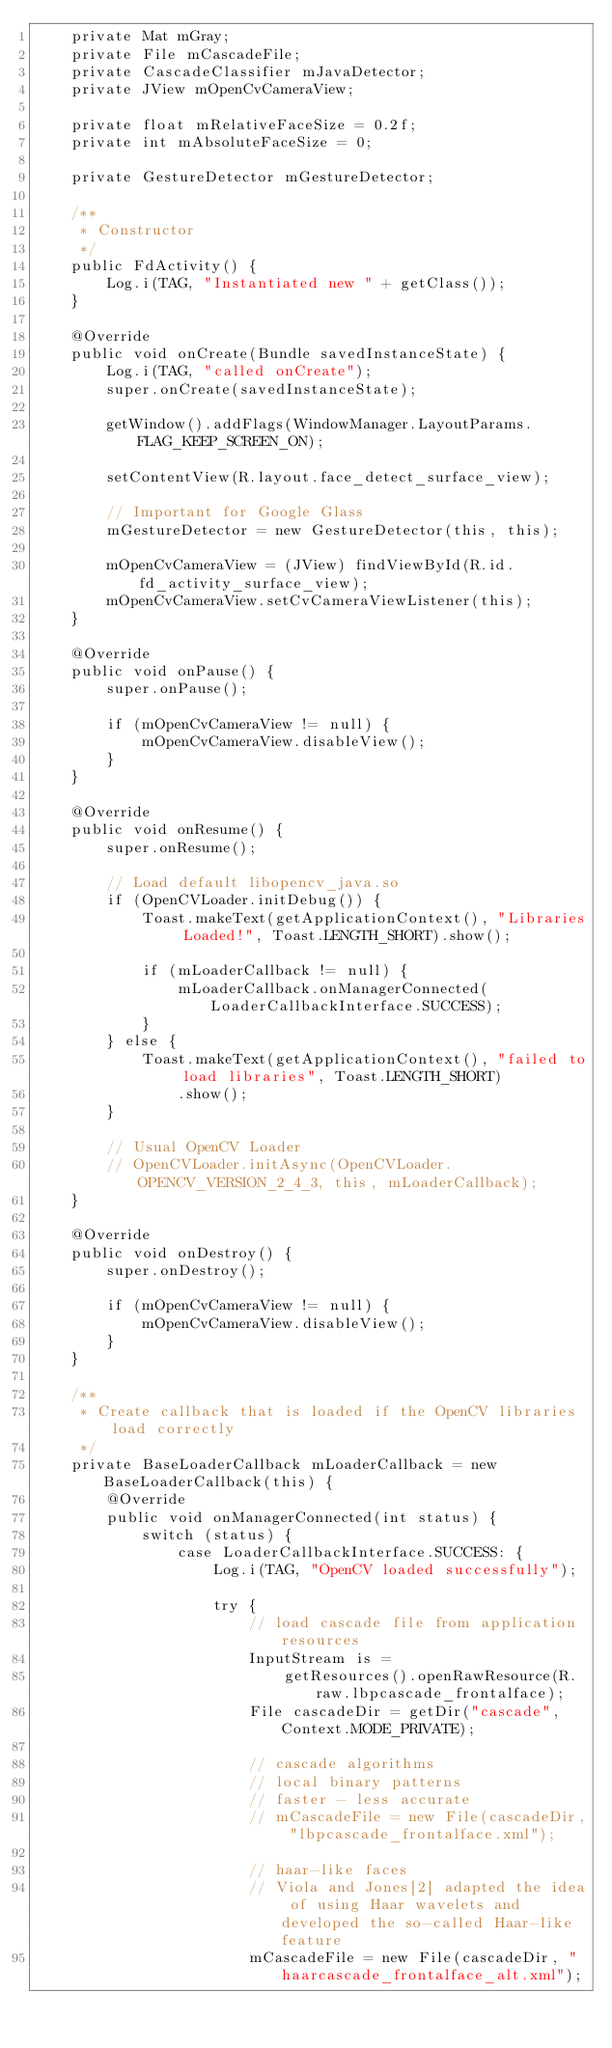<code> <loc_0><loc_0><loc_500><loc_500><_Java_>    private Mat mGray;
    private File mCascadeFile;
    private CascadeClassifier mJavaDetector;
    private JView mOpenCvCameraView;

    private float mRelativeFaceSize = 0.2f;
    private int mAbsoluteFaceSize = 0;

    private GestureDetector mGestureDetector;

    /**
     * Constructor
     */
    public FdActivity() {
        Log.i(TAG, "Instantiated new " + getClass());
    }

    @Override
    public void onCreate(Bundle savedInstanceState) {
        Log.i(TAG, "called onCreate");
        super.onCreate(savedInstanceState);

        getWindow().addFlags(WindowManager.LayoutParams.FLAG_KEEP_SCREEN_ON);

        setContentView(R.layout.face_detect_surface_view);

        // Important for Google Glass
        mGestureDetector = new GestureDetector(this, this);

        mOpenCvCameraView = (JView) findViewById(R.id.fd_activity_surface_view);
        mOpenCvCameraView.setCvCameraViewListener(this);
    }

    @Override
    public void onPause() {
        super.onPause();

        if (mOpenCvCameraView != null) {
            mOpenCvCameraView.disableView();
        }
    }

    @Override
    public void onResume() {
        super.onResume();

        // Load default libopencv_java.so
        if (OpenCVLoader.initDebug()) {
            Toast.makeText(getApplicationContext(), "Libraries Loaded!", Toast.LENGTH_SHORT).show();

            if (mLoaderCallback != null) {
                mLoaderCallback.onManagerConnected(LoaderCallbackInterface.SUCCESS);
            }
        } else {
            Toast.makeText(getApplicationContext(), "failed to load libraries", Toast.LENGTH_SHORT)
                .show();
        }

        // Usual OpenCV Loader
        // OpenCVLoader.initAsync(OpenCVLoader.OPENCV_VERSION_2_4_3, this, mLoaderCallback);
    }

    @Override
    public void onDestroy() {
        super.onDestroy();

        if (mOpenCvCameraView != null) {
            mOpenCvCameraView.disableView();
        }
    }

    /**
     * Create callback that is loaded if the OpenCV libraries load correctly
     */
    private BaseLoaderCallback mLoaderCallback = new BaseLoaderCallback(this) {
        @Override
        public void onManagerConnected(int status) {
            switch (status) {
                case LoaderCallbackInterface.SUCCESS: {
                    Log.i(TAG, "OpenCV loaded successfully");

                    try {
                        // load cascade file from application resources
                        InputStream is =
                            getResources().openRawResource(R.raw.lbpcascade_frontalface);
                        File cascadeDir = getDir("cascade", Context.MODE_PRIVATE);

                        // cascade algorithms
                        // local binary patterns
                        // faster - less accurate
                        // mCascadeFile = new File(cascadeDir, "lbpcascade_frontalface.xml");

                        // haar-like faces
                        // Viola and Jones[2] adapted the idea of using Haar wavelets and developed the so-called Haar-like feature
                        mCascadeFile = new File(cascadeDir, "haarcascade_frontalface_alt.xml");
</code> 